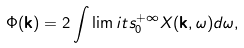<formula> <loc_0><loc_0><loc_500><loc_500>\Phi ( \mathbf k ) = 2 \int \lim i t s _ { 0 } ^ { + \infty } X ( \mathbf k , \omega ) d \omega ,</formula> 